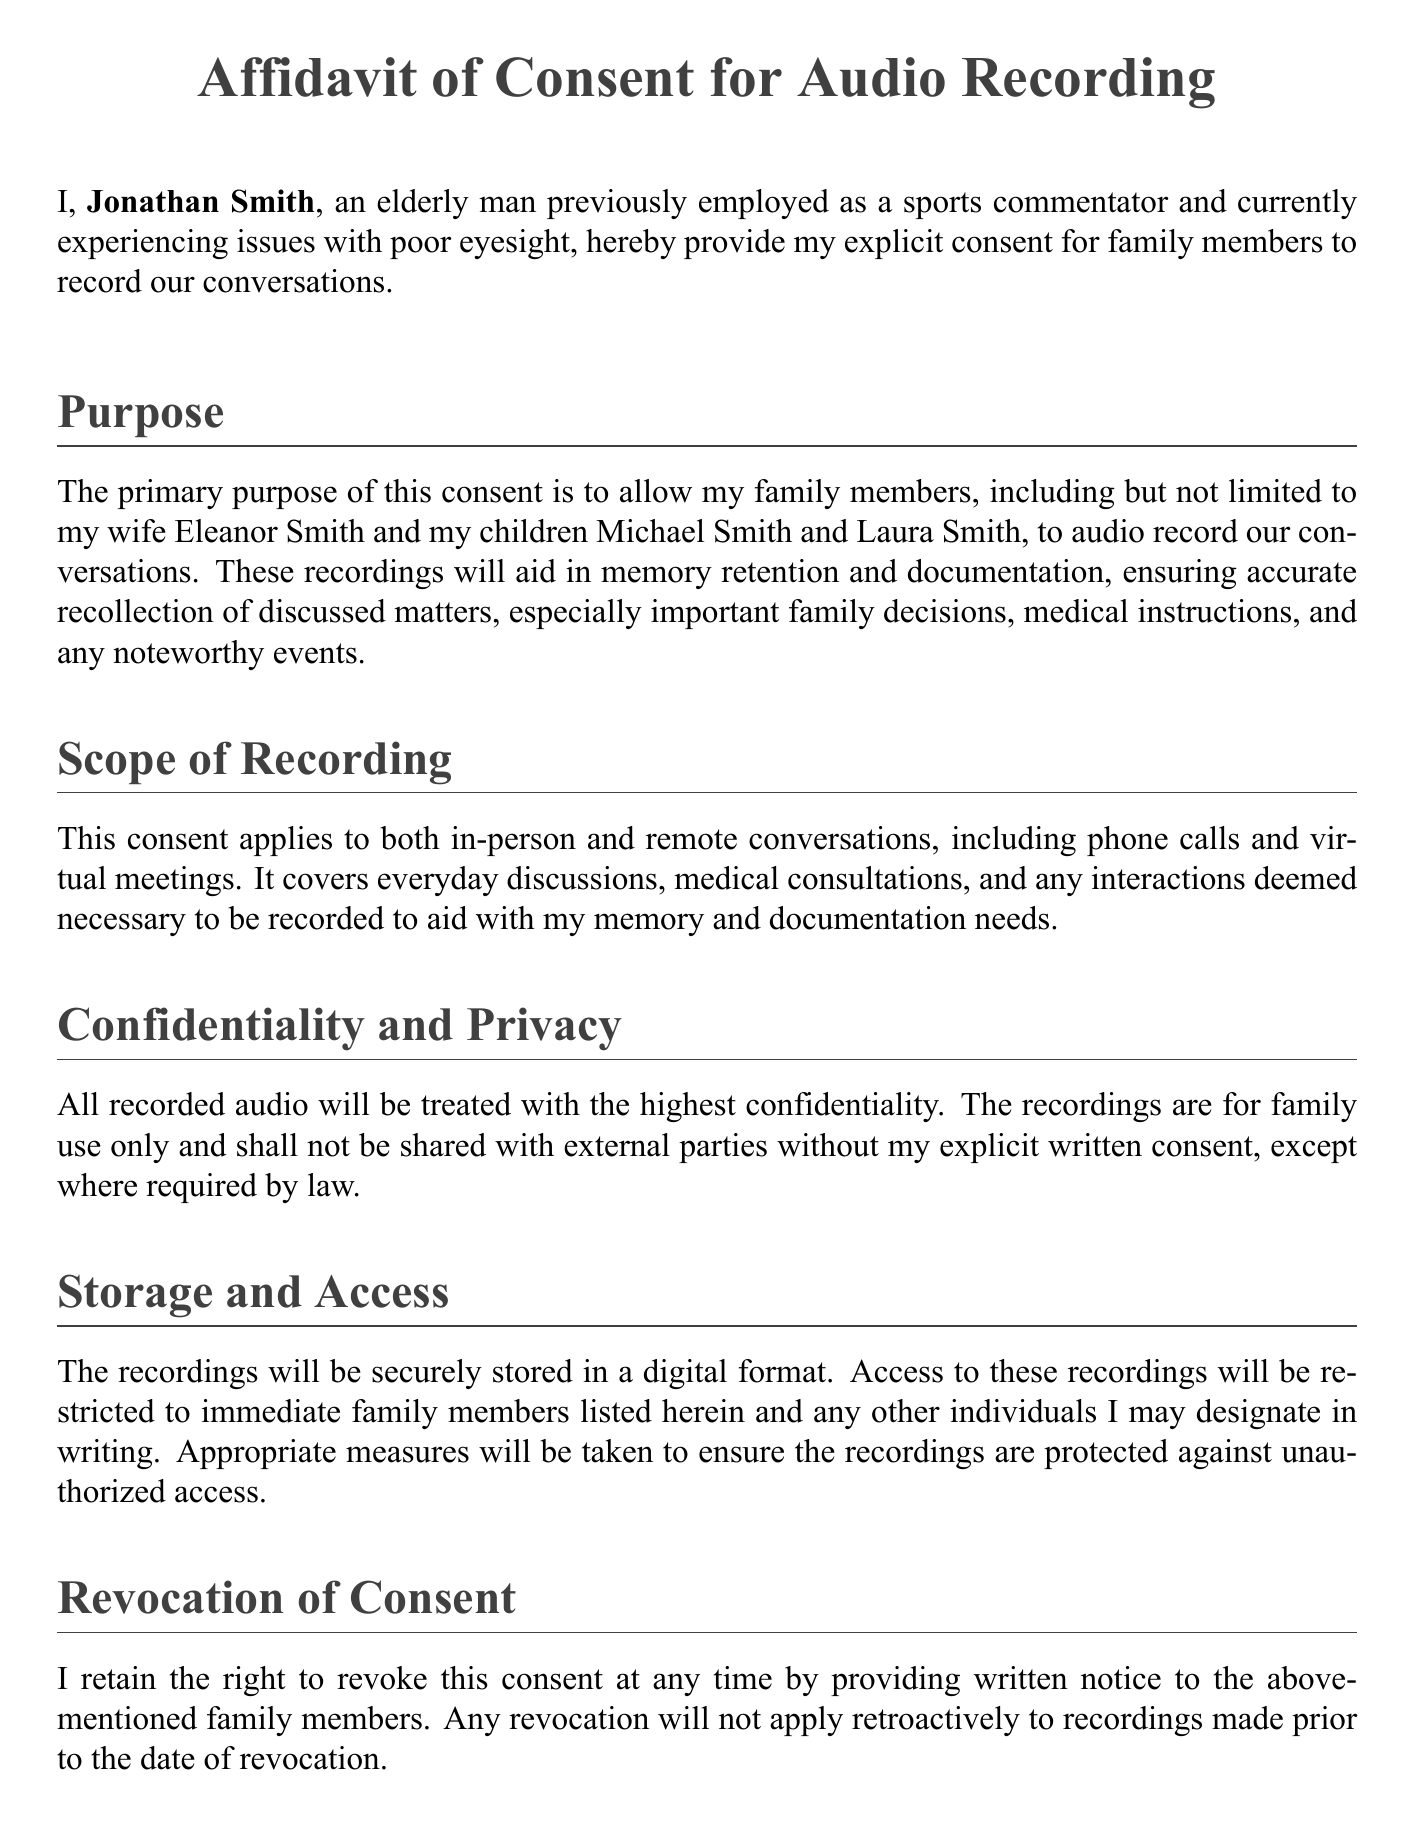What is the title of the document? The title is the main heading that indicates the purpose of the document, which is "Affidavit of Consent for Audio Recording."
Answer: Affidavit of Consent for Audio Recording Who is granting the consent? The individual who is providing consent is identified in the document as Jonathan Smith.
Answer: Jonathan Smith What are the names of the family members mentioned? Specific family members are listed in the purpose section, which includes Eleanor Smith, Michael Smith, and Laura Smith.
Answer: Eleanor Smith, Michael Smith, Laura Smith What is the date of the affidavit? The date at the end of the document indicates when the affidavit was signed, which is October 4, 2023.
Answer: October 4, 2023 What is the primary purpose of the consent? The primary purpose outlined in the document is to aid in memory retention and documentation of conversations.
Answer: Memory retention and documentation What right does Jonathan Smith retain regarding the consent? The document specifies that Jonathan Smith retains the right to revoke his consent at any time.
Answer: Revocation of consent What type of conversations does this consent apply to? The consent applies to both in-person and remote conversations, including phone calls and virtual meetings.
Answer: In-person and remote conversations What will happen to the recordings if consent is revoked? The document states that revocation of consent will not apply retroactively to recordings made prior to the date of revocation.
Answer: Not retroactive Who will have access to the recordings? Access is restricted to immediate family members listed in the document and any individuals Jonathan may designate in writing.
Answer: Immediate family members listed 